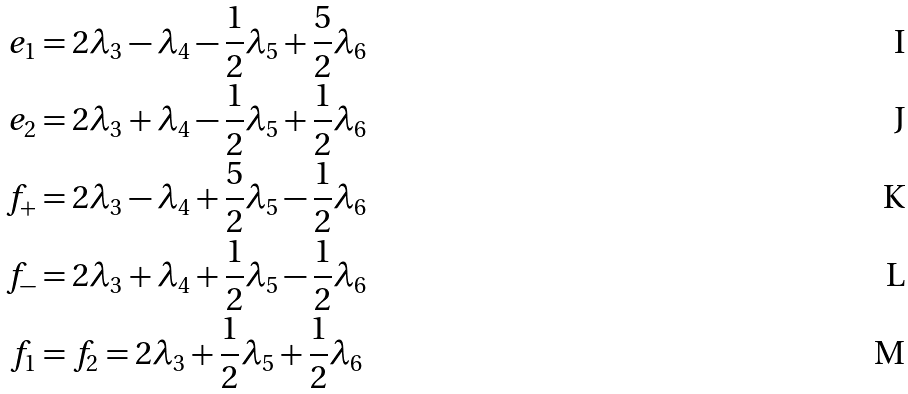<formula> <loc_0><loc_0><loc_500><loc_500>e _ { 1 } & = 2 \lambda _ { 3 } - \lambda _ { 4 } - \frac { 1 } { 2 } \lambda _ { 5 } + \frac { 5 } { 2 } \lambda _ { 6 } \\ e _ { 2 } & = 2 \lambda _ { 3 } + \lambda _ { 4 } - \frac { 1 } { 2 } \lambda _ { 5 } + \frac { 1 } { 2 } \lambda _ { 6 } \\ f _ { + } & = 2 \lambda _ { 3 } - \lambda _ { 4 } + \frac { 5 } { 2 } \lambda _ { 5 } - \frac { 1 } { 2 } \lambda _ { 6 } \\ f _ { - } & = 2 \lambda _ { 3 } + \lambda _ { 4 } + \frac { 1 } { 2 } \lambda _ { 5 } - \frac { 1 } { 2 } \lambda _ { 6 } \\ f _ { 1 } & = f _ { 2 } = 2 \lambda _ { 3 } + \frac { 1 } { 2 } \lambda _ { 5 } + \frac { 1 } { 2 } \lambda _ { 6 }</formula> 